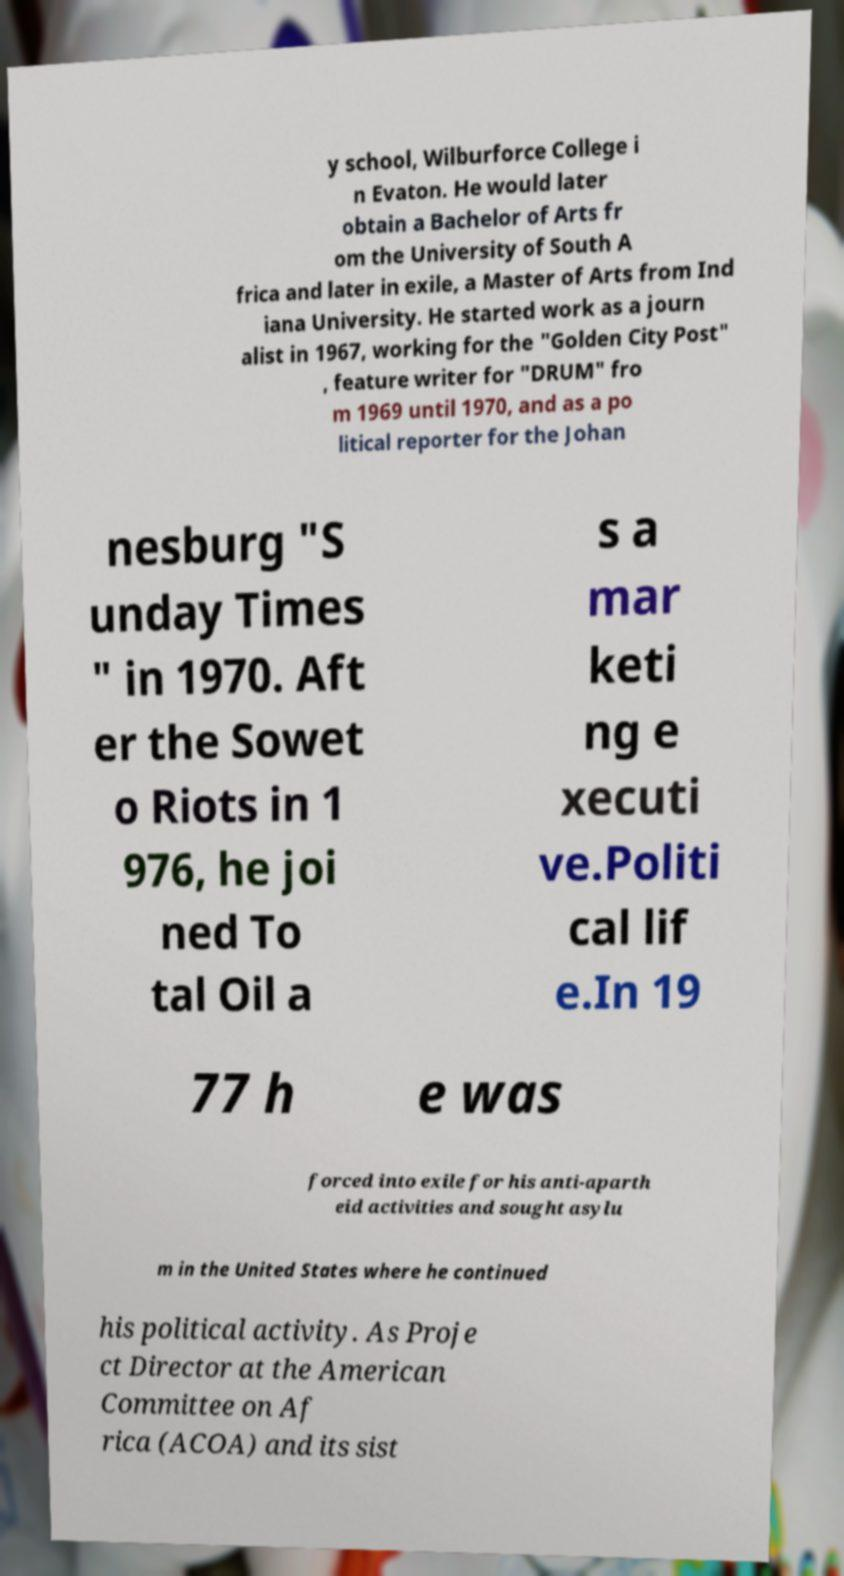Can you accurately transcribe the text from the provided image for me? y school, Wilburforce College i n Evaton. He would later obtain a Bachelor of Arts fr om the University of South A frica and later in exile, a Master of Arts from Ind iana University. He started work as a journ alist in 1967, working for the "Golden City Post" , feature writer for "DRUM" fro m 1969 until 1970, and as a po litical reporter for the Johan nesburg "S unday Times " in 1970. Aft er the Sowet o Riots in 1 976, he joi ned To tal Oil a s a mar keti ng e xecuti ve.Politi cal lif e.In 19 77 h e was forced into exile for his anti-aparth eid activities and sought asylu m in the United States where he continued his political activity. As Proje ct Director at the American Committee on Af rica (ACOA) and its sist 